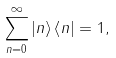<formula> <loc_0><loc_0><loc_500><loc_500>\overset { \infty } { \underset { n = 0 } { \sum } } \left | n \right \rangle \left \langle n \right | = 1 ,</formula> 